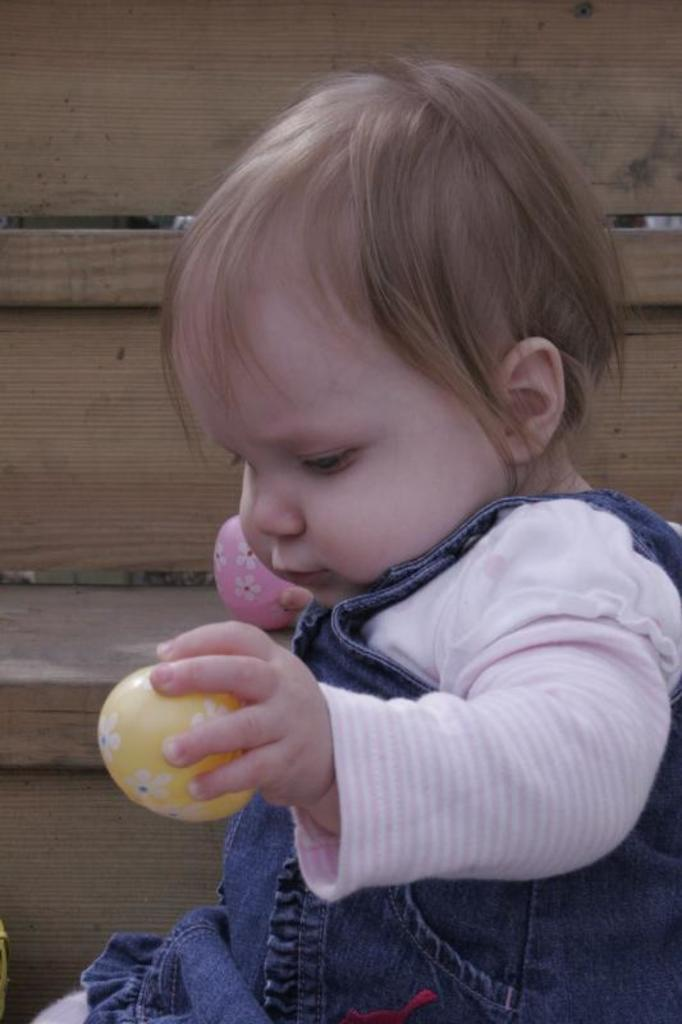What type of structure is present in the image? There is a wooden staircase in the image. Can you describe the person in the image? There is a kid in the image. What is the kid holding in the image? The kid is holding objects. What type of party is being held at the top of the staircase in the image? There is no indication of a party in the image; it only shows a wooden staircase and a kid holding objects. Can you tell me what kind of offer the kid is making to the person at the top of the staircase? There is no person at the top of the staircase in the image, and the kid is not making any offer. 